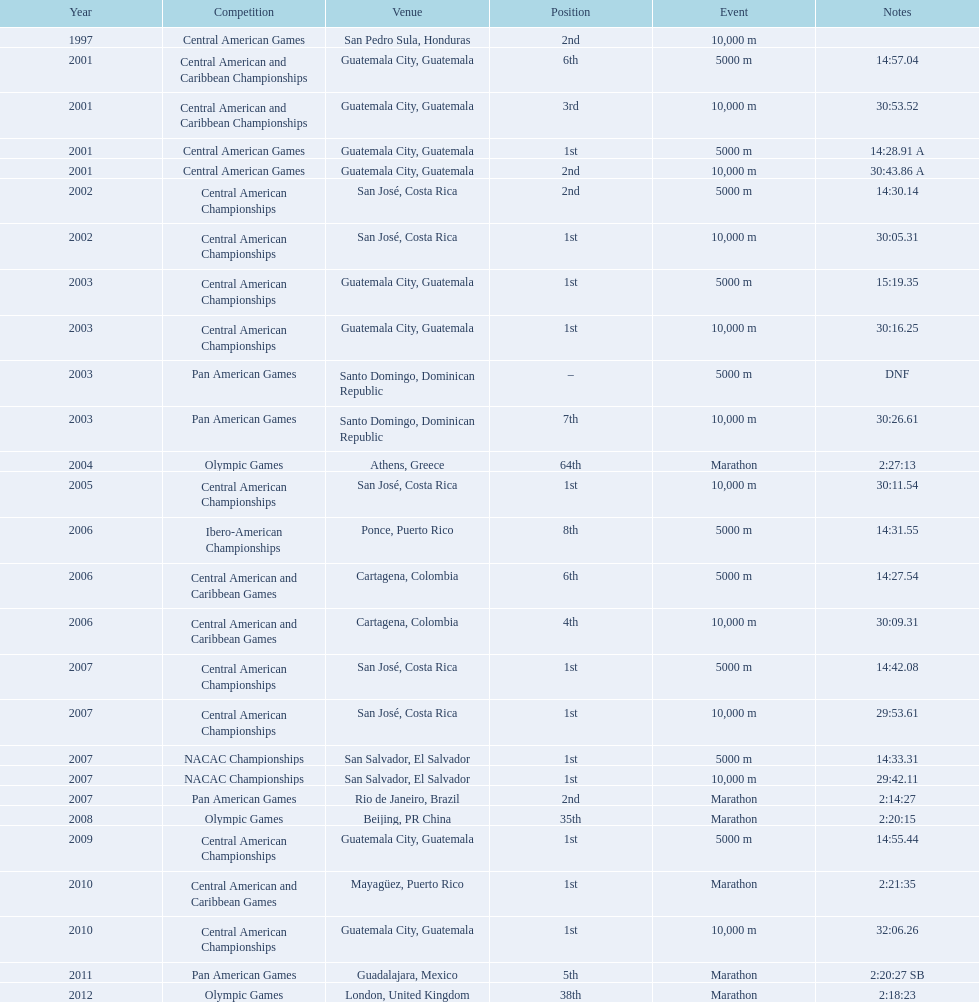How many times have they participated in competitions in guatemala? 5. 